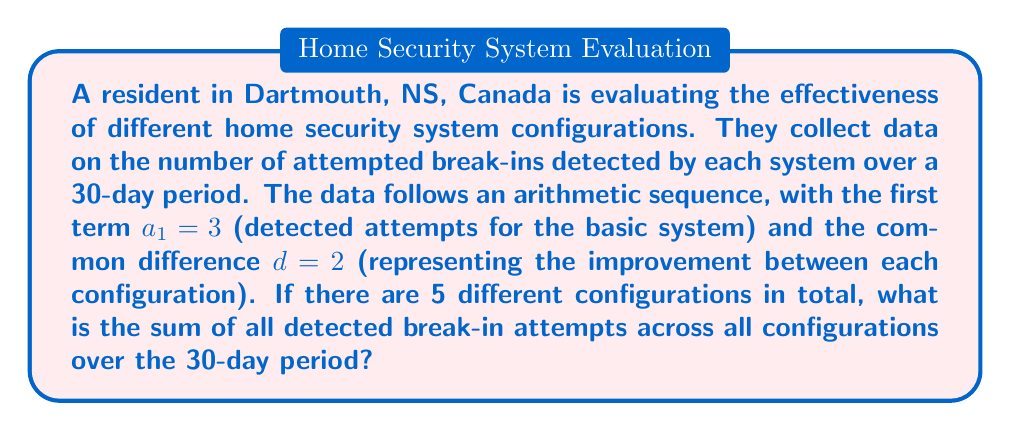Teach me how to tackle this problem. Let's approach this step-by-step:

1) We're dealing with an arithmetic sequence with 5 terms, where:
   $a_1 = 3$ (first term)
   $d = 2$ (common difference)
   $n = 5$ (number of terms)

2) The arithmetic sequence formula is:
   $a_n = a_1 + (n-1)d$

3) We can calculate the last term $a_5$:
   $a_5 = 3 + (5-1)2 = 3 + 8 = 11$

4) For the sum of an arithmetic sequence, we use the formula:
   $S_n = \frac{n}{2}(a_1 + a_n)$

5) Substituting our values:
   $S_5 = \frac{5}{2}(3 + 11) = \frac{5}{2}(14) = 35$

6) This sum represents the total detected attempts for one day across all configurations. Since we're looking at a 30-day period, we multiply by 30:

   $\text{Total detected attempts} = 35 \times 30 = 1050$

Therefore, the sum of all detected break-in attempts across all configurations over the 30-day period is 1050.
Answer: 1050 detected break-in attempts 